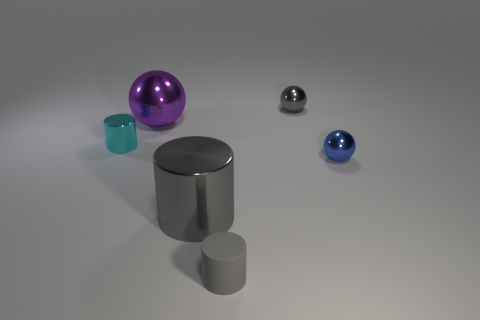There is a metallic ball in front of the small thing left of the gray matte thing; how big is it? The metallic ball in question appears modest in size relative to the other objects in the image. Judging by its proportion to the nearby shapes, it could be characterized as quite small, perhaps akin to a standard marble or a ping pong ball. 